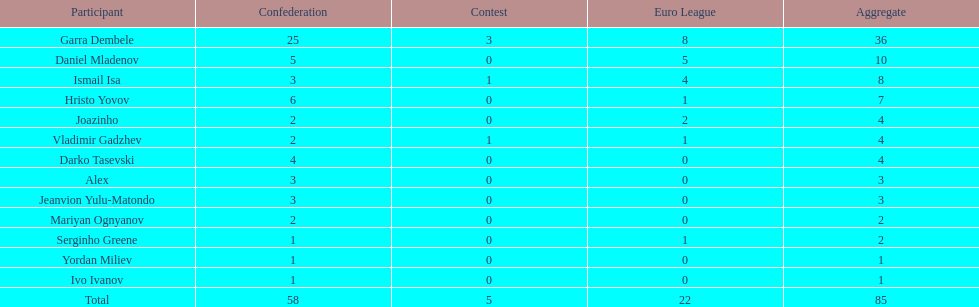What is the difference between vladimir gadzhev and yordan miliev's scores? 3. 